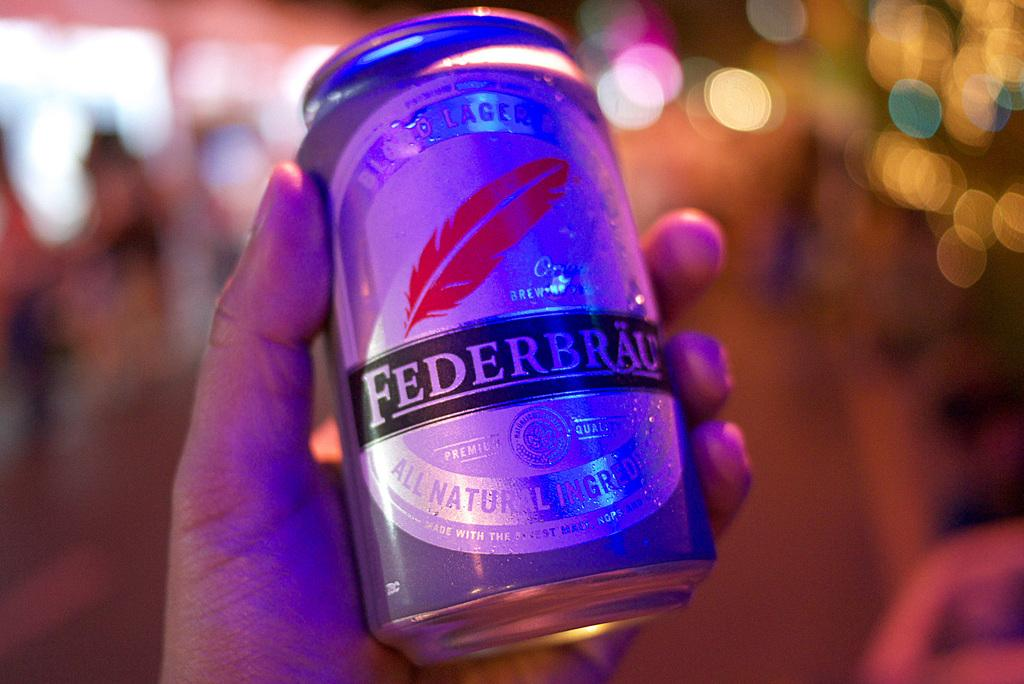Provide a one-sentence caption for the provided image. Man holding a can of beer by the maker Federbrau. 